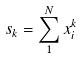Convert formula to latex. <formula><loc_0><loc_0><loc_500><loc_500>s _ { k } = \sum _ { 1 } ^ { N } x _ { i } ^ { k }</formula> 